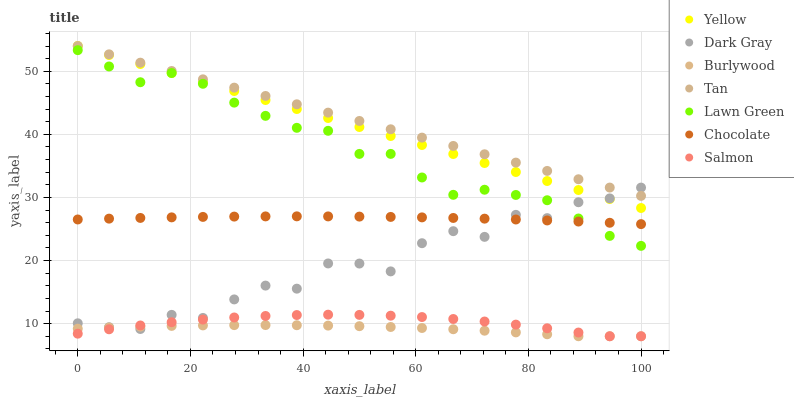Does Burlywood have the minimum area under the curve?
Answer yes or no. Yes. Does Tan have the maximum area under the curve?
Answer yes or no. Yes. Does Salmon have the minimum area under the curve?
Answer yes or no. No. Does Salmon have the maximum area under the curve?
Answer yes or no. No. Is Tan the smoothest?
Answer yes or no. Yes. Is Dark Gray the roughest?
Answer yes or no. Yes. Is Burlywood the smoothest?
Answer yes or no. No. Is Burlywood the roughest?
Answer yes or no. No. Does Burlywood have the lowest value?
Answer yes or no. Yes. Does Yellow have the lowest value?
Answer yes or no. No. Does Tan have the highest value?
Answer yes or no. Yes. Does Salmon have the highest value?
Answer yes or no. No. Is Salmon less than Lawn Green?
Answer yes or no. Yes. Is Tan greater than Salmon?
Answer yes or no. Yes. Does Salmon intersect Dark Gray?
Answer yes or no. Yes. Is Salmon less than Dark Gray?
Answer yes or no. No. Is Salmon greater than Dark Gray?
Answer yes or no. No. Does Salmon intersect Lawn Green?
Answer yes or no. No. 